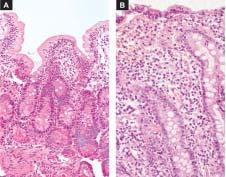s there near total flattening of the villi and crypt hyperplasia?
Answer the question using a single word or phrase. Yes 